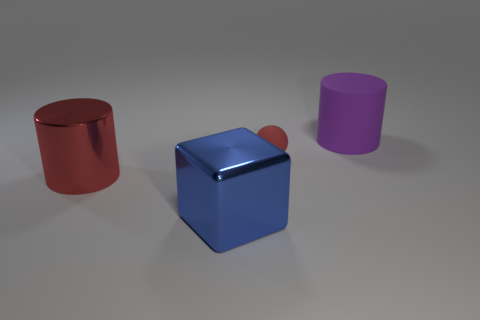What might be the relative sizes of the objects in the image? The red cylinder appears to be the largest in size, followed by the blue cube. The purple cylinder is smaller in diameter than the red one but similar in height. The red sphere on top of the blue cube is the smallest object, looking like a tiny button from this perspective. 